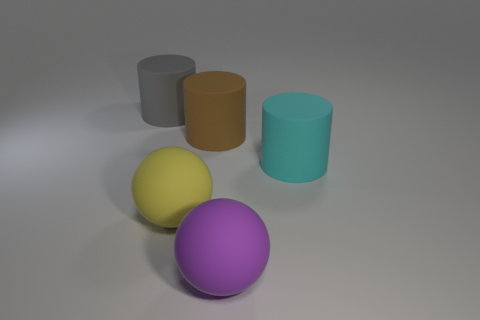If these objects were part of a scene in a child's playroom, what might be missing from the image to complete the scene? To complete a scene of a child's playroom, one might expect to see more variety in colors and sizes of the objects, perhaps additional toys like building blocks or dolls, a play mat with vibrant designs, and maybe some drawings or posters on the walls. 